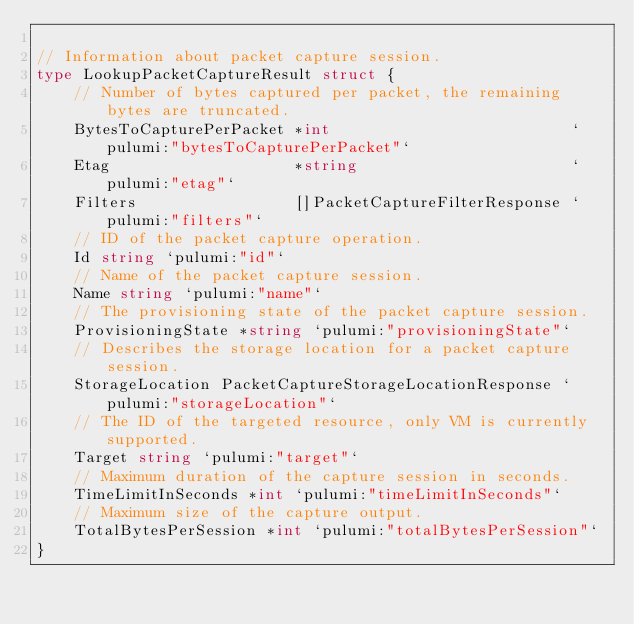<code> <loc_0><loc_0><loc_500><loc_500><_Go_>
// Information about packet capture session.
type LookupPacketCaptureResult struct {
	// Number of bytes captured per packet, the remaining bytes are truncated.
	BytesToCapturePerPacket *int                          `pulumi:"bytesToCapturePerPacket"`
	Etag                    *string                       `pulumi:"etag"`
	Filters                 []PacketCaptureFilterResponse `pulumi:"filters"`
	// ID of the packet capture operation.
	Id string `pulumi:"id"`
	// Name of the packet capture session.
	Name string `pulumi:"name"`
	// The provisioning state of the packet capture session.
	ProvisioningState *string `pulumi:"provisioningState"`
	// Describes the storage location for a packet capture session.
	StorageLocation PacketCaptureStorageLocationResponse `pulumi:"storageLocation"`
	// The ID of the targeted resource, only VM is currently supported.
	Target string `pulumi:"target"`
	// Maximum duration of the capture session in seconds.
	TimeLimitInSeconds *int `pulumi:"timeLimitInSeconds"`
	// Maximum size of the capture output.
	TotalBytesPerSession *int `pulumi:"totalBytesPerSession"`
}
</code> 